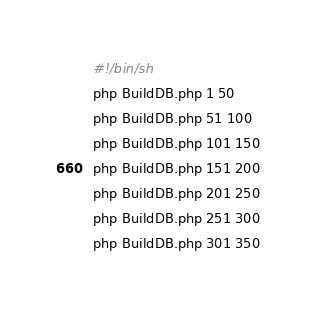<code> <loc_0><loc_0><loc_500><loc_500><_Bash_>#!/bin/sh
php BuildDB.php 1 50
php BuildDB.php 51 100
php BuildDB.php 101 150
php BuildDB.php 151 200
php BuildDB.php 201 250
php BuildDB.php 251 300
php BuildDB.php 301 350

</code> 